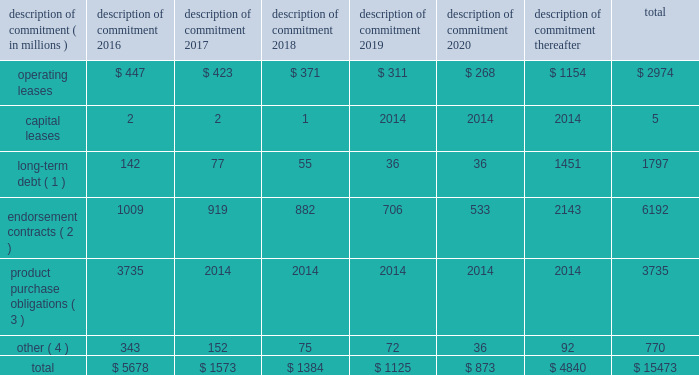Part ii were issued in an initial aggregate principal amount of $ 500 million at a 2.25% ( 2.25 % ) fixed , annual interest rate and will mature on may 1 , 2023 .
The 2043 senior notes were issued in an initial aggregate principal amount of $ 500 million at a 3.625% ( 3.625 % ) fixed , annual interest rate and will mature on may 1 , 2043 .
Interest on the senior notes is payable semi-annually on may 1 and november 1 of each year .
The issuance resulted in gross proceeds before expenses of $ 998 million .
On november 1 , 2011 , we entered into a committed credit facility agreement with a syndicate of banks which provides for up to $ 1 billion of borrowings with the option to increase borrowings to $ 1.5 billion with lender approval .
The facility matures november 1 , 2017 .
As of and for the periods ended may 31 , 2015 and 2014 , we had no amounts outstanding under our committed credit facility .
We currently have long-term debt ratings of aa- and a1 from standard and poor 2019s corporation and moody 2019s investor services , respectively .
If our long- term debt ratings were to decline , the facility fee and interest rate under our committed credit facility would increase .
Conversely , if our long-term debt rating were to improve , the facility fee and interest rate would decrease .
Changes in our long-term debt rating would not trigger acceleration of maturity of any then-outstanding borrowings or any future borrowings under the committed credit facility .
Under this committed revolving credit facility , we have agreed to various covenants .
These covenants include limits on our disposal of fixed assets , the amount of debt secured by liens we may incur , as well as a minimum capitalization ratio .
In the event we were to have any borrowings outstanding under this facility and failed to meet any covenant , and were unable to obtain a waiver from a majority of the banks in the syndicate , any borrowings would become immediately due and payable .
As of may 31 , 2015 , we were in full compliance with each of these covenants and believe it is unlikely we will fail to meet any of these covenants in the foreseeable future .
Liquidity is also provided by our $ 1 billion commercial paper program .
During the year ended may 31 , 2015 , we did not issue commercial paper , and as of may 31 , 2015 , there were no outstanding borrowings under this program .
We may issue commercial paper or other debt securities during fiscal 2016 depending on general corporate needs .
We currently have short-term debt ratings of a1+ and p1 from standard and poor 2019s corporation and moody 2019s investor services , respectively .
As of may 31 , 2015 , we had cash , cash equivalents and short-term investments totaling $ 5.9 billion , of which $ 4.2 billion was held by our foreign subsidiaries .
Included in cash and equivalents as of may 31 , 2015 was $ 968 million of cash collateral received from counterparties as a result of hedging activity .
Cash equivalents and short-term investments consist primarily of deposits held at major banks , money market funds , commercial paper , corporate notes , u.s .
Treasury obligations , u.s .
Government sponsored enterprise obligations and other investment grade fixed income securities .
Our fixed income investments are exposed to both credit and interest rate risk .
All of our investments are investment grade to minimize our credit risk .
While individual securities have varying durations , as of may 31 , 2015 the weighted average remaining duration of our short-term investments and cash equivalents portfolio was 79 days .
To date we have not experienced difficulty accessing the credit markets or incurred higher interest costs .
Future volatility in the capital markets , however , may increase costs associated with issuing commercial paper or other debt instruments or affect our ability to access those markets .
We believe that existing cash , cash equivalents , short-term investments and cash generated by operations , together with access to external sources of funds as described above , will be sufficient to meet our domestic and foreign capital needs in the foreseeable future .
We utilize a variety of tax planning and financing strategies to manage our worldwide cash and deploy funds to locations where they are needed .
We routinely repatriate a portion of our foreign earnings for which u.s .
Taxes have previously been provided .
We also indefinitely reinvest a significant portion of our foreign earnings , and our current plans do not demonstrate a need to repatriate these earnings .
Should we require additional capital in the united states , we may elect to repatriate indefinitely reinvested foreign funds or raise capital in the united states through debt .
If we were to repatriate indefinitely reinvested foreign funds , we would be required to accrue and pay additional u.s .
Taxes less applicable foreign tax credits .
If we elect to raise capital in the united states through debt , we would incur additional interest expense .
Off-balance sheet arrangements in connection with various contracts and agreements , we routinely provide indemnification relating to the enforceability of intellectual property rights , coverage for legal issues that arise and other items where we are acting as the guarantor .
Currently , we have several such agreements in place .
However , based on our historical experience and the estimated probability of future loss , we have determined that the fair value of such indemnification is not material to our financial position or results of operations .
Contractual obligations our significant long-term contractual obligations as of may 31 , 2015 and significant endorsement contracts , including related marketing commitments , entered into through the date of this report are as follows: .
( 1 ) the cash payments due for long-term debt include estimated interest payments .
Estimates of interest payments are based on outstanding principal amounts , applicable fixed interest rates or currently effective interest rates as of may 31 , 2015 ( if variable ) , timing of scheduled payments and the term of the debt obligations .
( 2 ) the amounts listed for endorsement contracts represent approximate amounts of base compensation and minimum guaranteed royalty fees we are obligated to pay athlete , sport team and league endorsers of our products .
Actual payments under some contracts may be higher than the amounts listed as these contracts provide for bonuses to be paid to the endorsers based upon athletic achievements and/or royalties on product sales in future periods .
Actual payments under some contracts may also be lower as these contracts include provisions for reduced payments if athletic performance declines in future periods .
In addition to the cash payments , we are obligated to furnish our endorsers with nike product for their use .
It is not possible to determine how much we will spend on this product on an annual basis as the contracts generally do not stipulate a specific amount of cash to be spent on the product .
The amount of product provided to the endorsers will depend on many factors , including general playing conditions , the number of sporting events in which they participate and our own decisions regarding product and marketing initiatives .
In addition , the costs to design , develop , source and purchase the products furnished to the endorsers are incurred over a period of time and are not necessarily tracked separately from similar costs incurred for products sold to customers. .
What percentage of endorsement contracts is currently due in 2016? 
Computations: (1009 / 6192)
Answer: 0.16295. 